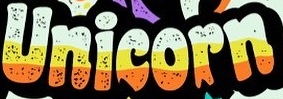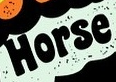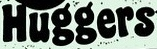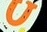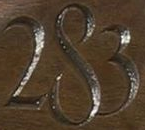What words can you see in these images in sequence, separated by a semicolon? Unicorn; Horse; Huggers; U; 283 